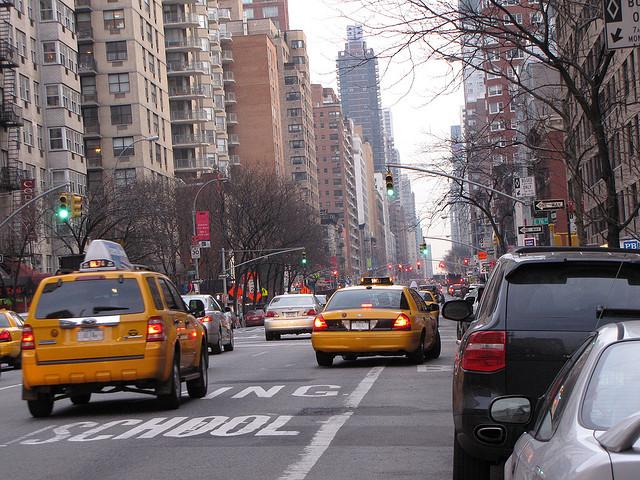What side of the street are we looking from?
Answer briefly. Right. Is the light green?
Short answer required. Yes. Are all the vehicles moving?
Be succinct. No. How many taxis are there?
Be succinct. 2. 